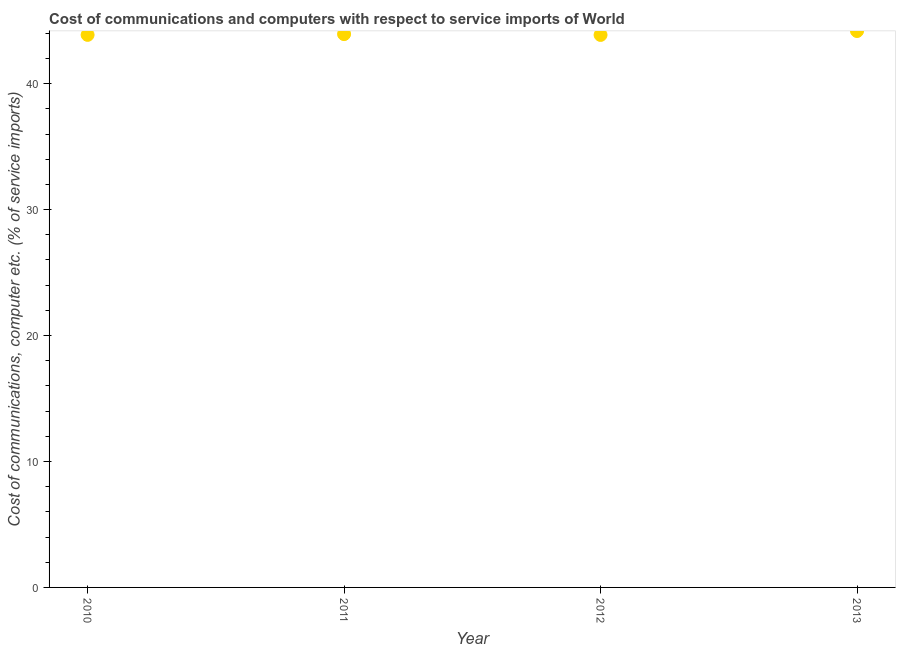What is the cost of communications and computer in 2013?
Make the answer very short. 44.18. Across all years, what is the maximum cost of communications and computer?
Your answer should be compact. 44.18. Across all years, what is the minimum cost of communications and computer?
Offer a very short reply. 43.87. In which year was the cost of communications and computer maximum?
Provide a succinct answer. 2013. What is the sum of the cost of communications and computer?
Provide a succinct answer. 175.86. What is the difference between the cost of communications and computer in 2011 and 2012?
Your response must be concise. 0.06. What is the average cost of communications and computer per year?
Give a very brief answer. 43.96. What is the median cost of communications and computer?
Your answer should be very brief. 43.9. In how many years, is the cost of communications and computer greater than 14 %?
Make the answer very short. 4. What is the ratio of the cost of communications and computer in 2011 to that in 2013?
Offer a terse response. 0.99. Is the difference between the cost of communications and computer in 2012 and 2013 greater than the difference between any two years?
Provide a succinct answer. Yes. What is the difference between the highest and the second highest cost of communications and computer?
Your response must be concise. 0.25. Is the sum of the cost of communications and computer in 2010 and 2011 greater than the maximum cost of communications and computer across all years?
Give a very brief answer. Yes. What is the difference between the highest and the lowest cost of communications and computer?
Offer a very short reply. 0.31. In how many years, is the cost of communications and computer greater than the average cost of communications and computer taken over all years?
Keep it short and to the point. 1. Are the values on the major ticks of Y-axis written in scientific E-notation?
Offer a terse response. No. Does the graph contain any zero values?
Offer a very short reply. No. What is the title of the graph?
Offer a terse response. Cost of communications and computers with respect to service imports of World. What is the label or title of the X-axis?
Your answer should be compact. Year. What is the label or title of the Y-axis?
Provide a succinct answer. Cost of communications, computer etc. (% of service imports). What is the Cost of communications, computer etc. (% of service imports) in 2010?
Make the answer very short. 43.87. What is the Cost of communications, computer etc. (% of service imports) in 2011?
Ensure brevity in your answer.  43.93. What is the Cost of communications, computer etc. (% of service imports) in 2012?
Offer a very short reply. 43.87. What is the Cost of communications, computer etc. (% of service imports) in 2013?
Give a very brief answer. 44.18. What is the difference between the Cost of communications, computer etc. (% of service imports) in 2010 and 2011?
Give a very brief answer. -0.06. What is the difference between the Cost of communications, computer etc. (% of service imports) in 2010 and 2012?
Keep it short and to the point. 0. What is the difference between the Cost of communications, computer etc. (% of service imports) in 2010 and 2013?
Keep it short and to the point. -0.31. What is the difference between the Cost of communications, computer etc. (% of service imports) in 2011 and 2012?
Your answer should be compact. 0.06. What is the difference between the Cost of communications, computer etc. (% of service imports) in 2011 and 2013?
Provide a short and direct response. -0.25. What is the difference between the Cost of communications, computer etc. (% of service imports) in 2012 and 2013?
Keep it short and to the point. -0.31. What is the ratio of the Cost of communications, computer etc. (% of service imports) in 2011 to that in 2012?
Your answer should be compact. 1. What is the ratio of the Cost of communications, computer etc. (% of service imports) in 2011 to that in 2013?
Give a very brief answer. 0.99. 